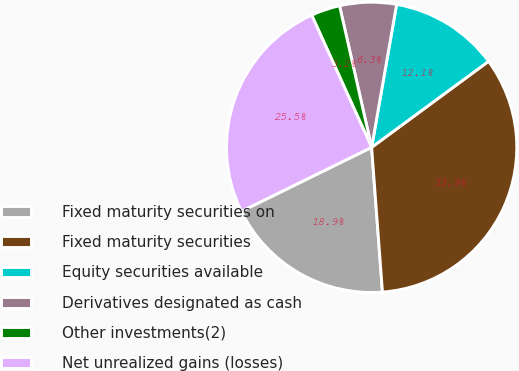Convert chart. <chart><loc_0><loc_0><loc_500><loc_500><pie_chart><fcel>Fixed maturity securities on<fcel>Fixed maturity securities<fcel>Equity securities available<fcel>Derivatives designated as cash<fcel>Other investments(2)<fcel>Net unrealized gains (losses)<nl><fcel>18.92%<fcel>33.91%<fcel>12.15%<fcel>6.3%<fcel>3.23%<fcel>25.49%<nl></chart> 